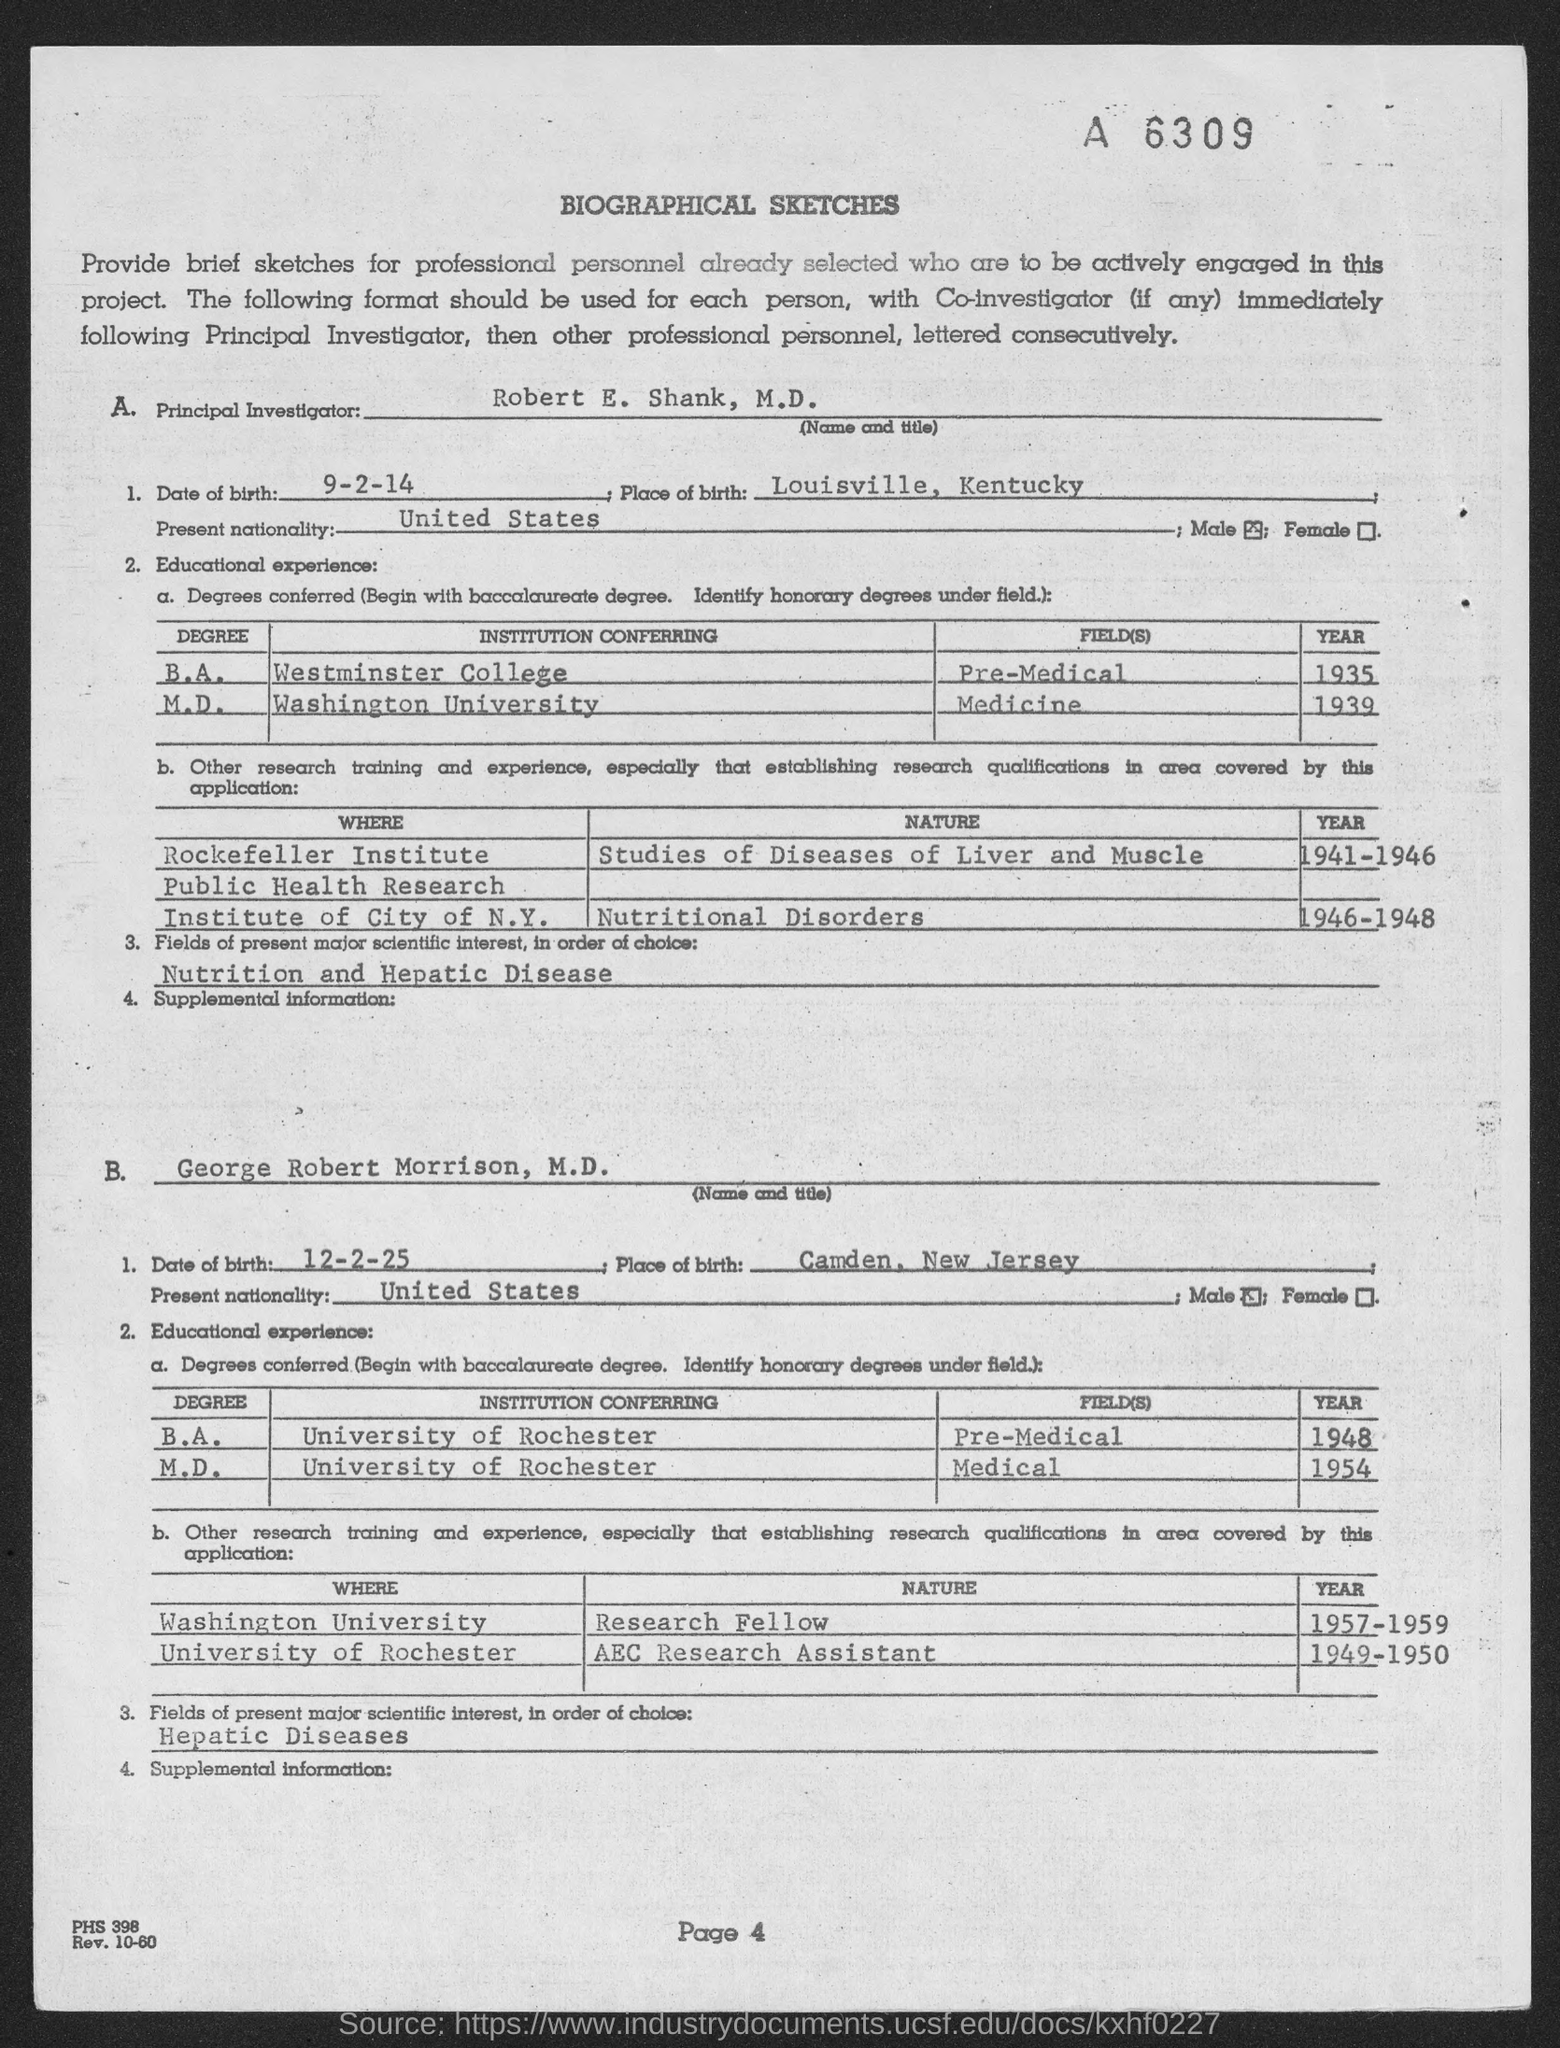Highlight a few significant elements in this photo. George Robert Morrison was born in Camden, New Jersey. The date of birth of Robert E. Shank is September 2, 2014. The date of birth of George Robert Morrison is December 2, 1893. Robert E. Shank was born in Louisville, Kentucky. The page number is 4. 